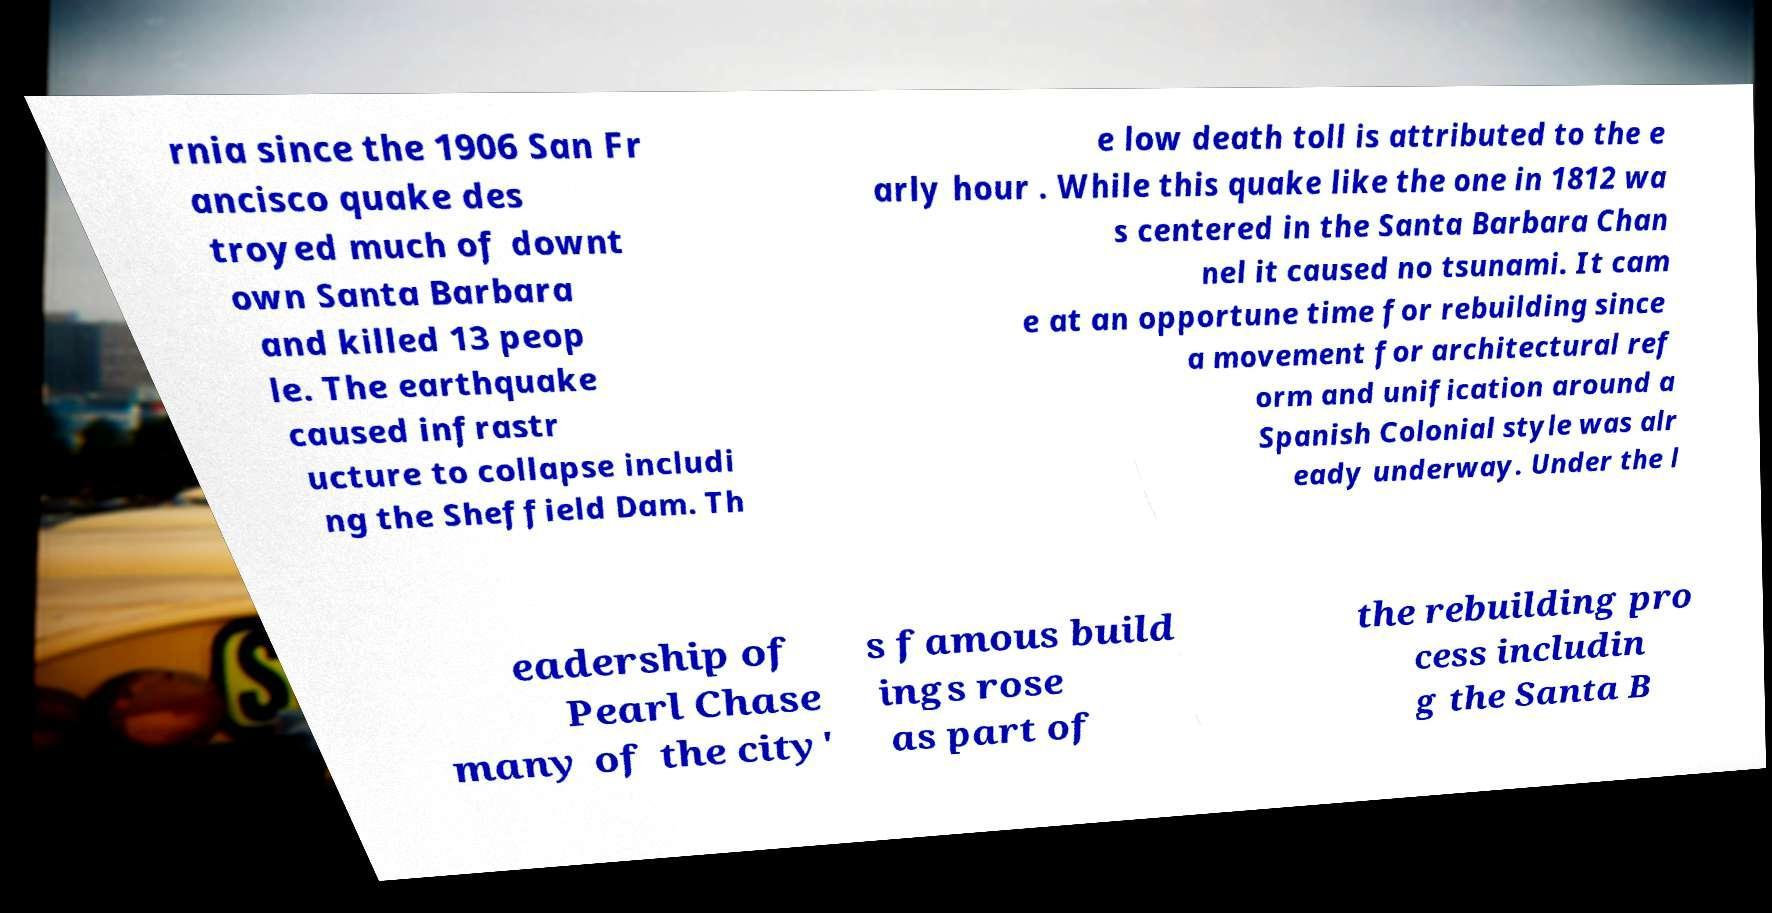Can you read and provide the text displayed in the image?This photo seems to have some interesting text. Can you extract and type it out for me? rnia since the 1906 San Fr ancisco quake des troyed much of downt own Santa Barbara and killed 13 peop le. The earthquake caused infrastr ucture to collapse includi ng the Sheffield Dam. Th e low death toll is attributed to the e arly hour . While this quake like the one in 1812 wa s centered in the Santa Barbara Chan nel it caused no tsunami. It cam e at an opportune time for rebuilding since a movement for architectural ref orm and unification around a Spanish Colonial style was alr eady underway. Under the l eadership of Pearl Chase many of the city' s famous build ings rose as part of the rebuilding pro cess includin g the Santa B 